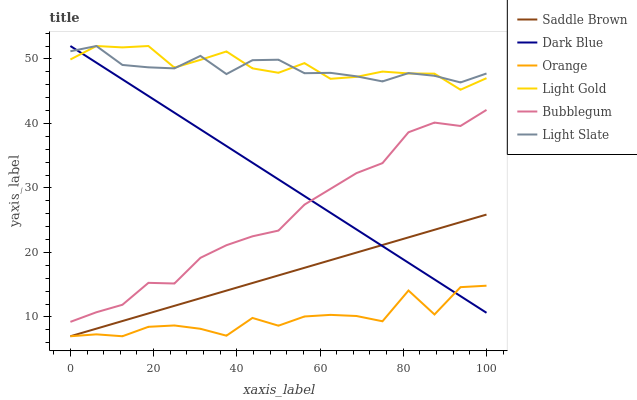Does Orange have the minimum area under the curve?
Answer yes or no. Yes. Does Light Gold have the maximum area under the curve?
Answer yes or no. Yes. Does Bubblegum have the minimum area under the curve?
Answer yes or no. No. Does Bubblegum have the maximum area under the curve?
Answer yes or no. No. Is Saddle Brown the smoothest?
Answer yes or no. Yes. Is Orange the roughest?
Answer yes or no. Yes. Is Bubblegum the smoothest?
Answer yes or no. No. Is Bubblegum the roughest?
Answer yes or no. No. Does Orange have the lowest value?
Answer yes or no. Yes. Does Bubblegum have the lowest value?
Answer yes or no. No. Does Light Gold have the highest value?
Answer yes or no. Yes. Does Bubblegum have the highest value?
Answer yes or no. No. Is Saddle Brown less than Bubblegum?
Answer yes or no. Yes. Is Bubblegum greater than Saddle Brown?
Answer yes or no. Yes. Does Bubblegum intersect Dark Blue?
Answer yes or no. Yes. Is Bubblegum less than Dark Blue?
Answer yes or no. No. Is Bubblegum greater than Dark Blue?
Answer yes or no. No. Does Saddle Brown intersect Bubblegum?
Answer yes or no. No. 